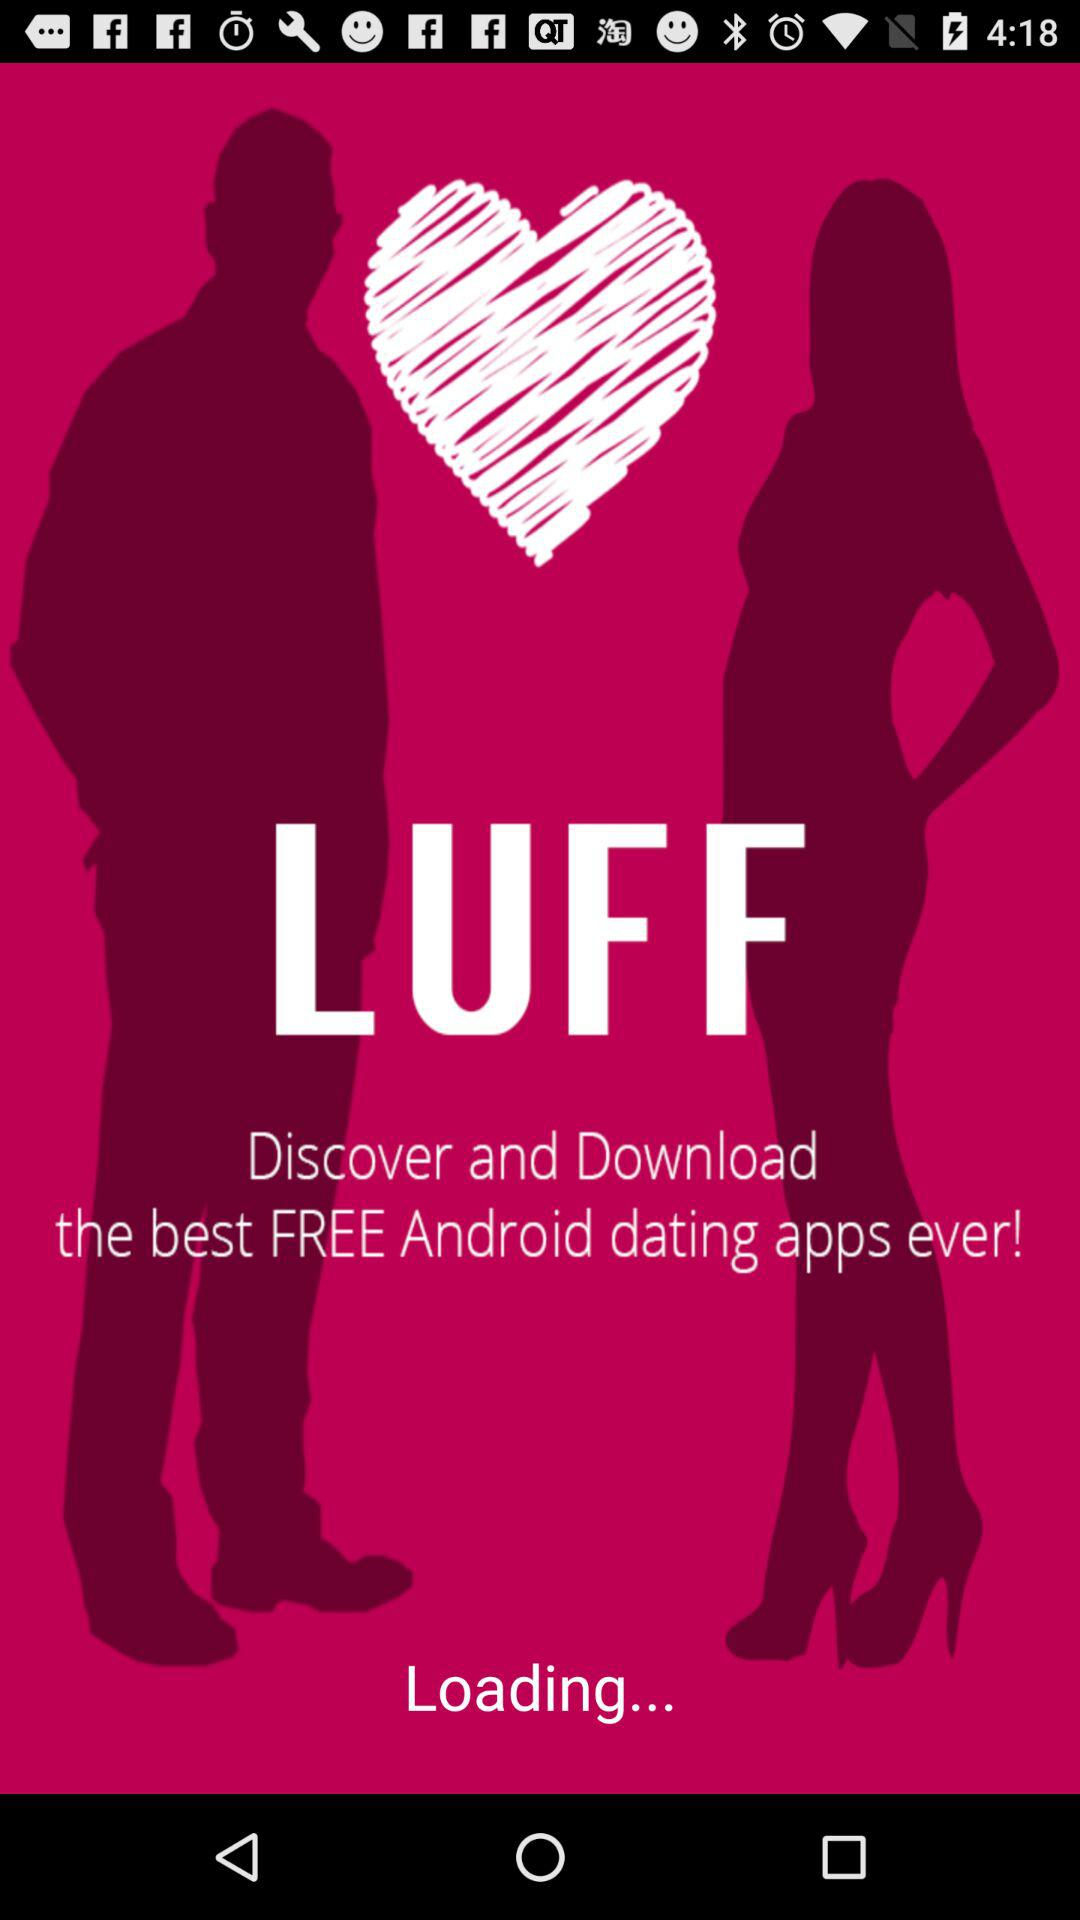What is the name of application? The name of the application is "LUFF". 